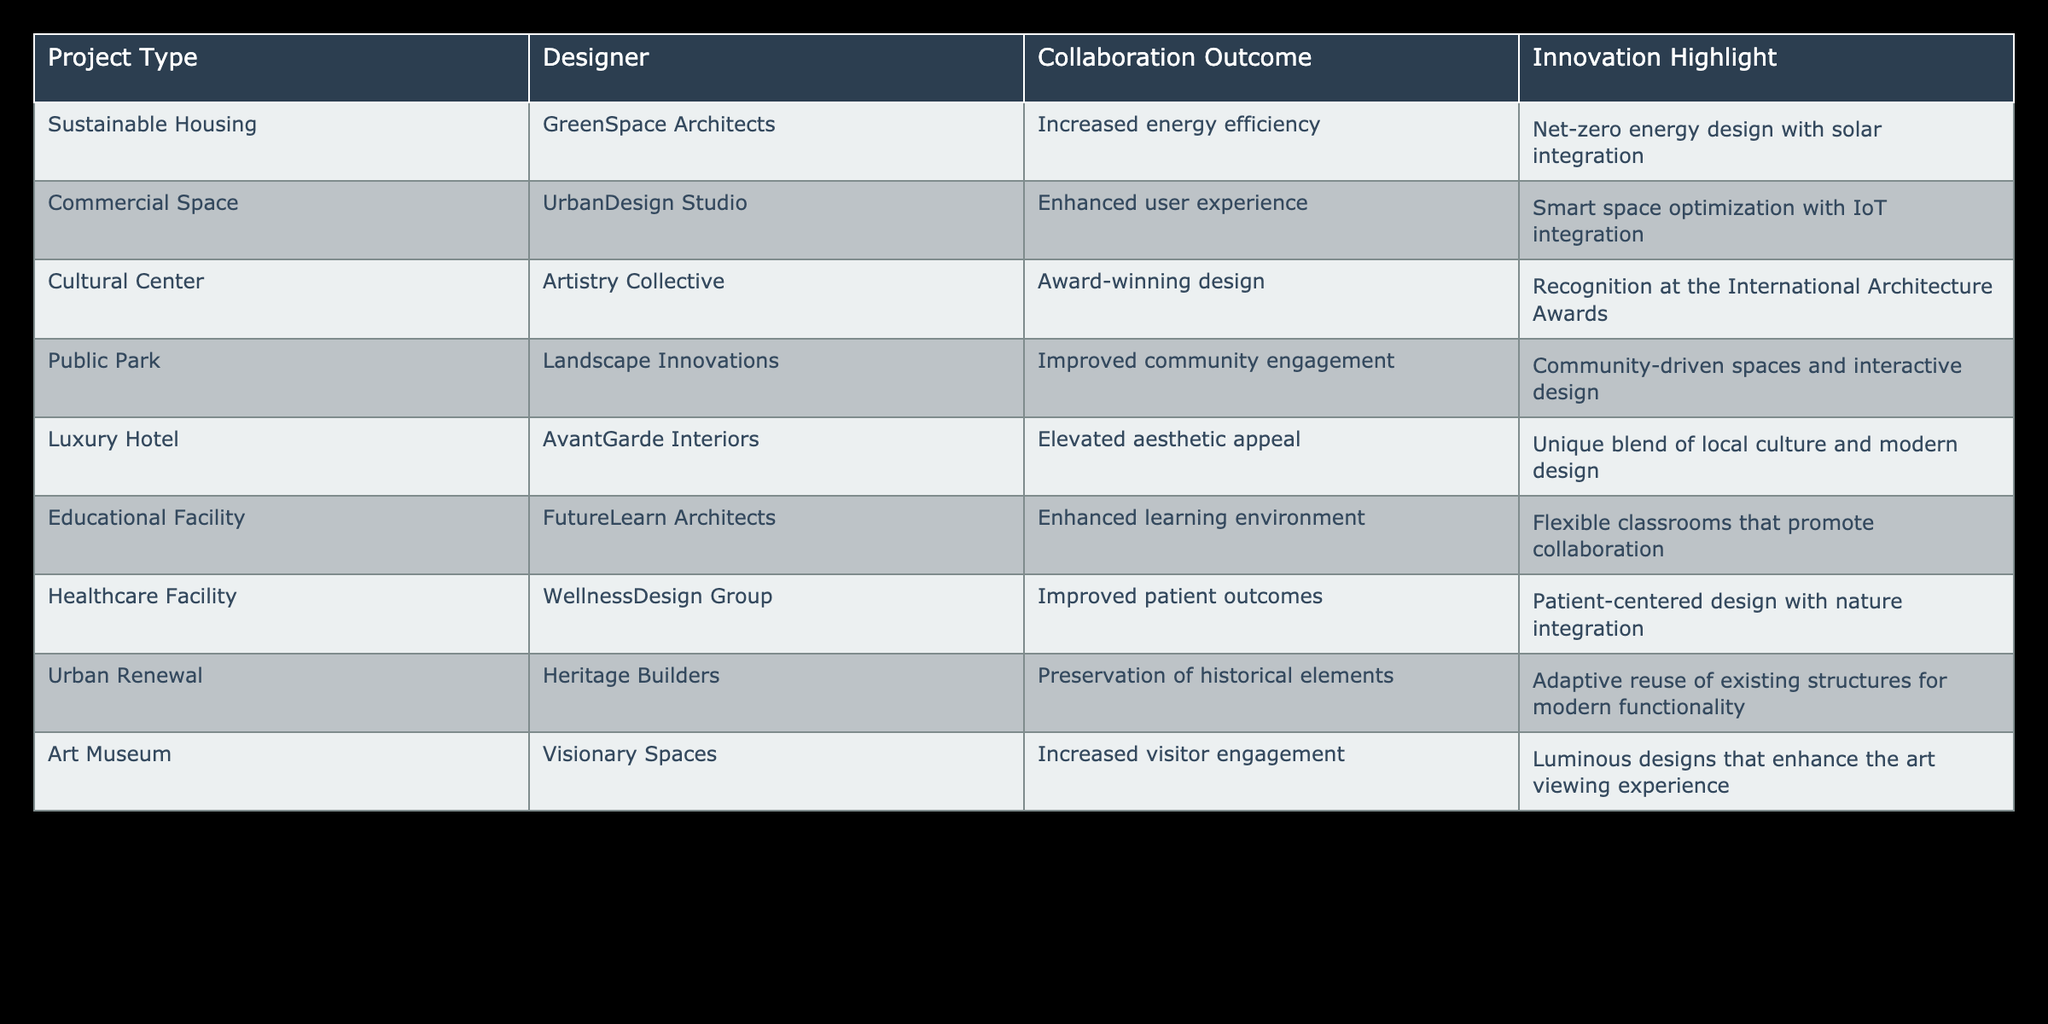What is the collaboration outcome for the Sustainable Housing project? The table lists "Increased energy efficiency" as the collaboration outcome for the Sustainable Housing project, which is directly visible in the table under the respective column for outcomes.
Answer: Increased energy efficiency Which designer collaborated on the Cultural Center project? Referring to the table, the designer associated with the Cultural Center project is "Artistry Collective", as indicated in the Designer column for that specific row.
Answer: Artistry Collective Is there a project outcome that highlights improved community engagement? Looking at the table, the project outcome showing "Improved community engagement" belongs to the Public Park project, confirming that such an outcome is present in the data.
Answer: Yes How many projects involved designers that resulted in an award-winning design? The table shows that only one project, the Cultural Center, has the outcome of "Award-winning design". Therefore, the count of such projects is 1.
Answer: 1 What is the average number of collaboration outcomes related to aesthetic appeal across all projects? The Luxury Hotel project outcome cites "Elevated aesthetic appeal", but it is the only project highlighted in the table related to aesthetics. Since there is only one instance, the average is simply 1/1 = 1.
Answer: 1 Which project type had a collaboration outcome focused on enhanced user experience? The table indicates that the Commercial Space project features the outcome "Enhanced user experience", providing clear identification of this project type and its related outcome.
Answer: Commercial Space Was there a project in the table that resulted in patient-centered design? Checking the healthcare facility listed in the table, it states "Patient-centered design with nature integration" as its outcome, confirming the presence of such a project.
Answer: Yes What is the innovation highlight for the Urban Renewal project? In the table, under the Urban Renewal project, the innovation highlight listed is "Adaptive reuse of existing structures for modern functionality", providing a clear understanding of this project’s innovative aspects.
Answer: Adaptive reuse of existing structures for modern functionality Which projects have collaboration outcomes that include community-driven spaces? The Public Park project is noted for its outcome of "Community-driven spaces and interactive design" in the table, identifying it as the sole project with this specific outcome, making it unique in that regard.
Answer: Public Park 